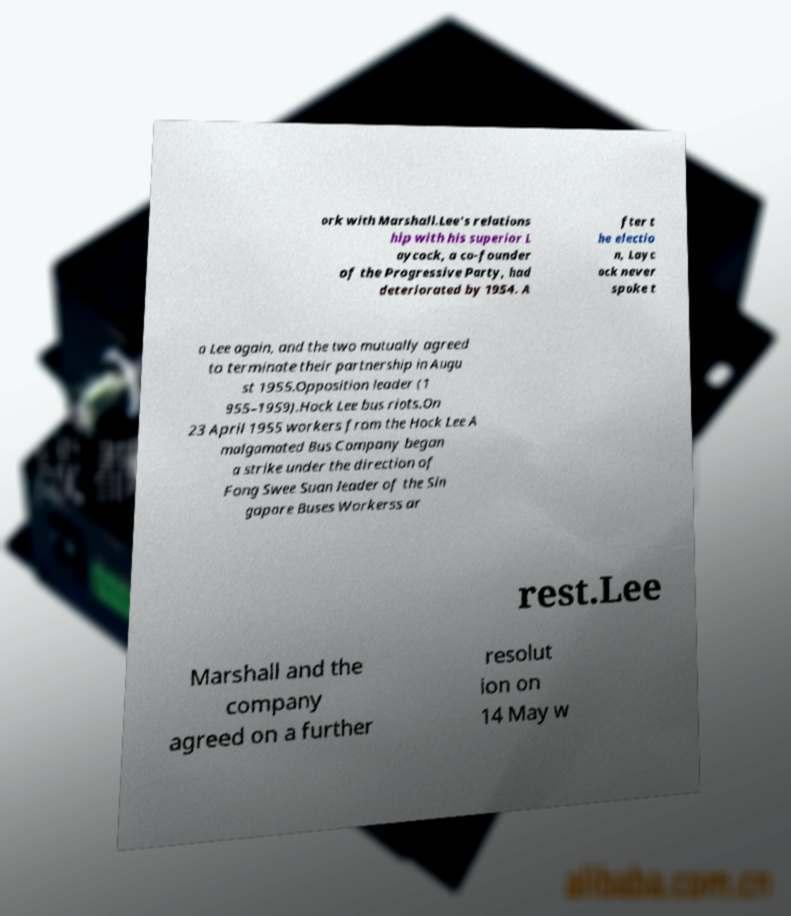I need the written content from this picture converted into text. Can you do that? ork with Marshall.Lee's relations hip with his superior L aycock, a co-founder of the Progressive Party, had deteriorated by 1954. A fter t he electio n, Layc ock never spoke t o Lee again, and the two mutually agreed to terminate their partnership in Augu st 1955.Opposition leader (1 955–1959).Hock Lee bus riots.On 23 April 1955 workers from the Hock Lee A malgamated Bus Company began a strike under the direction of Fong Swee Suan leader of the Sin gapore Buses Workerss ar rest.Lee Marshall and the company agreed on a further resolut ion on 14 May w 